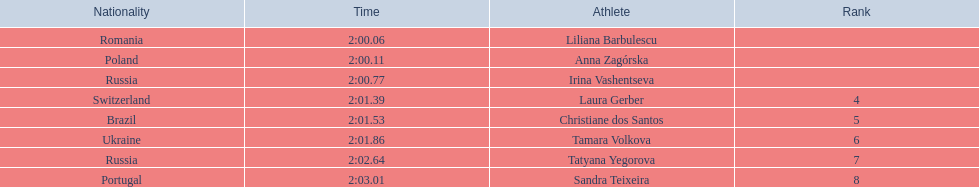Who came in second place at the athletics at the 2003 summer universiade - women's 800 metres? Anna Zagórska. What was her time? 2:00.11. 